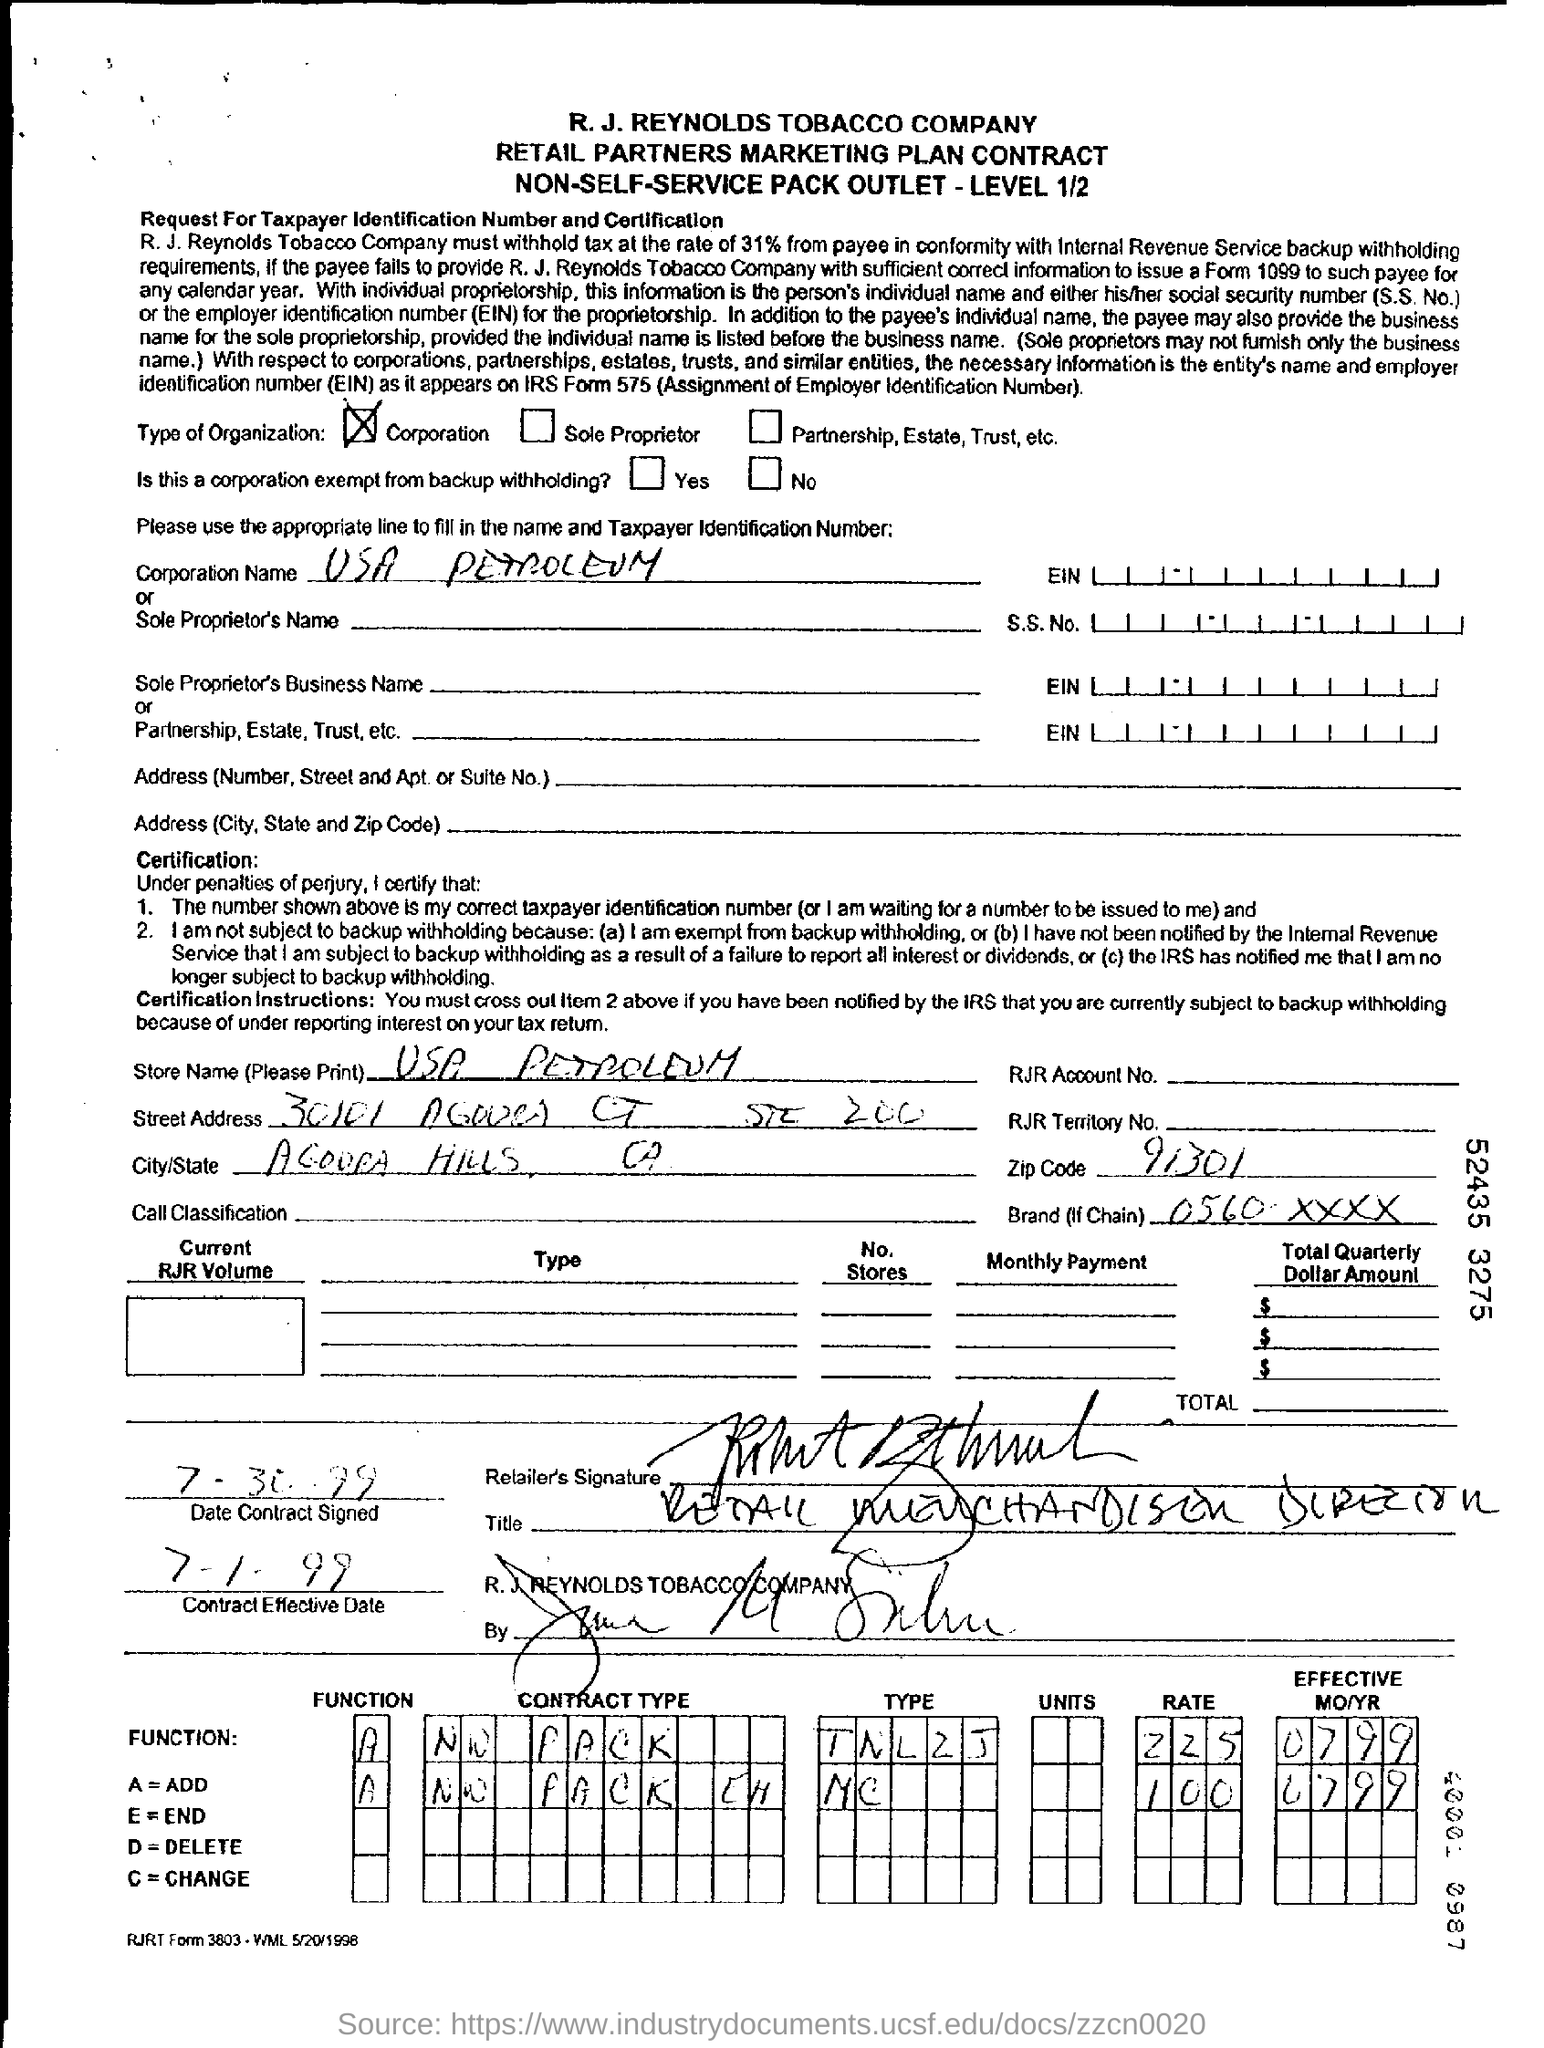Identify some key points in this picture. The store name specified in the contract is USA Petroleum. The contract's effective date, as stated in the document, is July 1, 1999. The zip code specified in the contract form is 91301. 